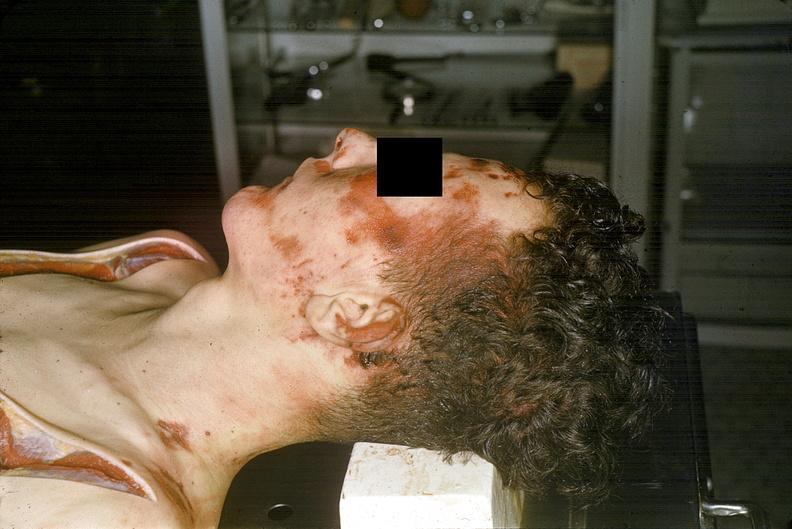does this image show head and face, severe trauma, contusion, lacerations, abrasions?
Answer the question using a single word or phrase. Yes 